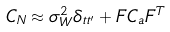Convert formula to latex. <formula><loc_0><loc_0><loc_500><loc_500>C _ { N } \approx \sigma _ { W } ^ { 2 } \delta _ { t t ^ { \prime } } + F C _ { a } F ^ { T }</formula> 